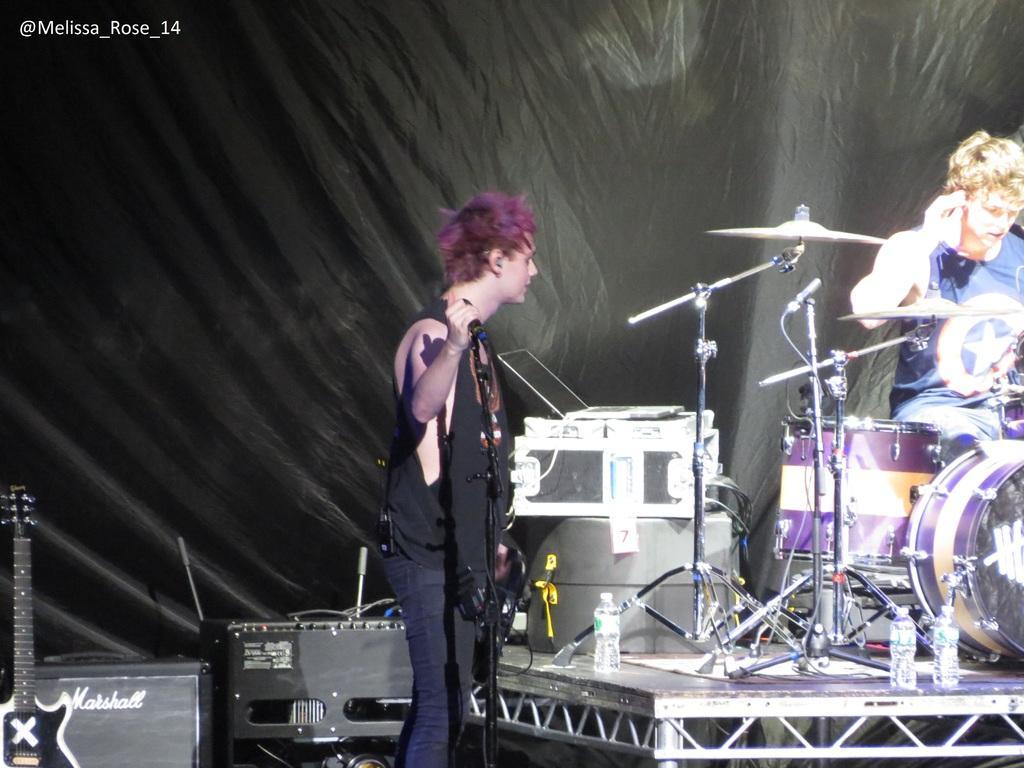Can you describe this image briefly? In the image we can see there is a person standing and other person is sitting near the drumset. There are water bottles kept on the stage and there are other musical instruments kept on the stage. 